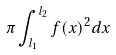Convert formula to latex. <formula><loc_0><loc_0><loc_500><loc_500>\pi \int _ { l _ { 1 } } ^ { l _ { 2 } } f ( x ) ^ { 2 } d x</formula> 